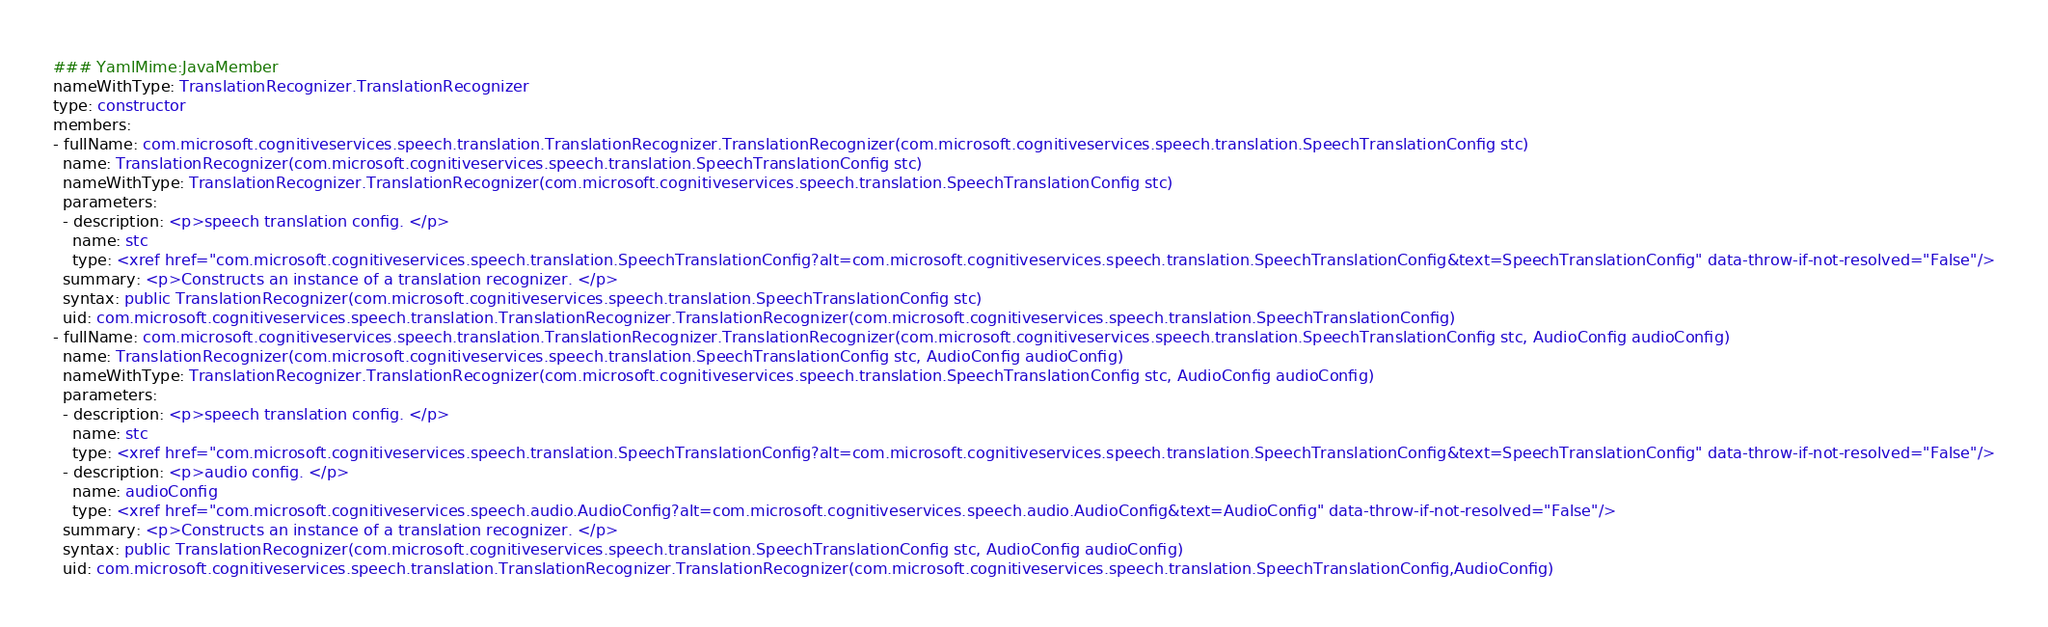<code> <loc_0><loc_0><loc_500><loc_500><_YAML_>### YamlMime:JavaMember
nameWithType: TranslationRecognizer.TranslationRecognizer
type: constructor
members:
- fullName: com.microsoft.cognitiveservices.speech.translation.TranslationRecognizer.TranslationRecognizer(com.microsoft.cognitiveservices.speech.translation.SpeechTranslationConfig stc)
  name: TranslationRecognizer(com.microsoft.cognitiveservices.speech.translation.SpeechTranslationConfig stc)
  nameWithType: TranslationRecognizer.TranslationRecognizer(com.microsoft.cognitiveservices.speech.translation.SpeechTranslationConfig stc)
  parameters:
  - description: <p>speech translation config. </p>
    name: stc
    type: <xref href="com.microsoft.cognitiveservices.speech.translation.SpeechTranslationConfig?alt=com.microsoft.cognitiveservices.speech.translation.SpeechTranslationConfig&text=SpeechTranslationConfig" data-throw-if-not-resolved="False"/>
  summary: <p>Constructs an instance of a translation recognizer. </p>
  syntax: public TranslationRecognizer(com.microsoft.cognitiveservices.speech.translation.SpeechTranslationConfig stc)
  uid: com.microsoft.cognitiveservices.speech.translation.TranslationRecognizer.TranslationRecognizer(com.microsoft.cognitiveservices.speech.translation.SpeechTranslationConfig)
- fullName: com.microsoft.cognitiveservices.speech.translation.TranslationRecognizer.TranslationRecognizer(com.microsoft.cognitiveservices.speech.translation.SpeechTranslationConfig stc, AudioConfig audioConfig)
  name: TranslationRecognizer(com.microsoft.cognitiveservices.speech.translation.SpeechTranslationConfig stc, AudioConfig audioConfig)
  nameWithType: TranslationRecognizer.TranslationRecognizer(com.microsoft.cognitiveservices.speech.translation.SpeechTranslationConfig stc, AudioConfig audioConfig)
  parameters:
  - description: <p>speech translation config. </p>
    name: stc
    type: <xref href="com.microsoft.cognitiveservices.speech.translation.SpeechTranslationConfig?alt=com.microsoft.cognitiveservices.speech.translation.SpeechTranslationConfig&text=SpeechTranslationConfig" data-throw-if-not-resolved="False"/>
  - description: <p>audio config. </p>
    name: audioConfig
    type: <xref href="com.microsoft.cognitiveservices.speech.audio.AudioConfig?alt=com.microsoft.cognitiveservices.speech.audio.AudioConfig&text=AudioConfig" data-throw-if-not-resolved="False"/>
  summary: <p>Constructs an instance of a translation recognizer. </p>
  syntax: public TranslationRecognizer(com.microsoft.cognitiveservices.speech.translation.SpeechTranslationConfig stc, AudioConfig audioConfig)
  uid: com.microsoft.cognitiveservices.speech.translation.TranslationRecognizer.TranslationRecognizer(com.microsoft.cognitiveservices.speech.translation.SpeechTranslationConfig,AudioConfig)</code> 